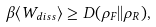<formula> <loc_0><loc_0><loc_500><loc_500>\beta \langle W _ { d i s s } \rangle \geq D ( \rho _ { F } | | \rho _ { R } ) ,</formula> 